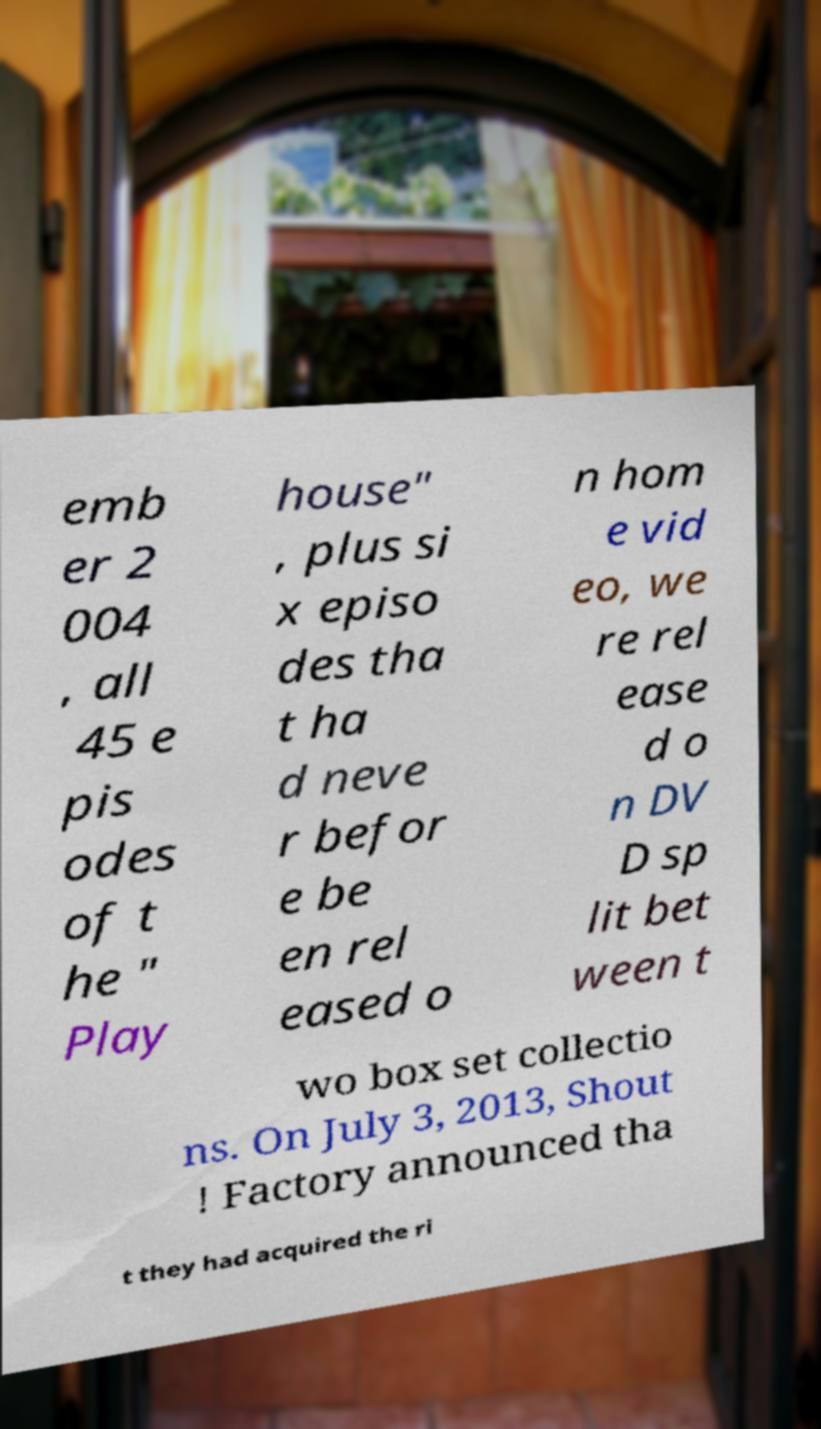For documentation purposes, I need the text within this image transcribed. Could you provide that? emb er 2 004 , all 45 e pis odes of t he " Play house" , plus si x episo des tha t ha d neve r befor e be en rel eased o n hom e vid eo, we re rel ease d o n DV D sp lit bet ween t wo box set collectio ns. On July 3, 2013, Shout ! Factory announced tha t they had acquired the ri 